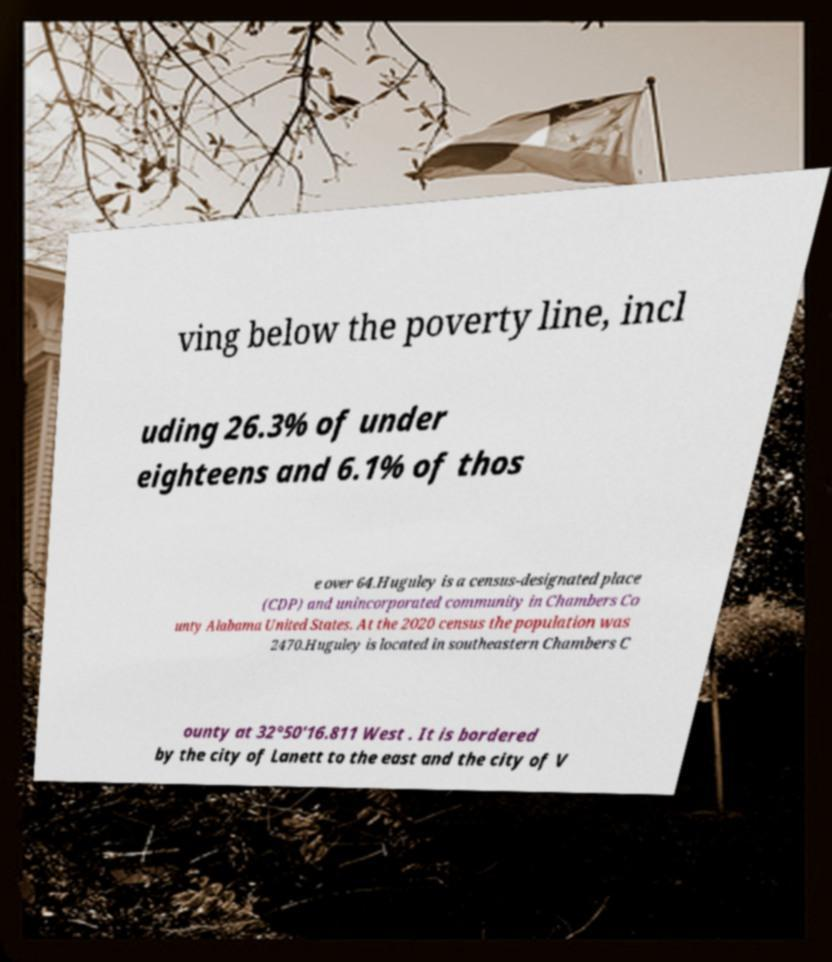Can you accurately transcribe the text from the provided image for me? ving below the poverty line, incl uding 26.3% of under eighteens and 6.1% of thos e over 64.Huguley is a census-designated place (CDP) and unincorporated community in Chambers Co unty Alabama United States. At the 2020 census the population was 2470.Huguley is located in southeastern Chambers C ounty at 32°50'16.811 West . It is bordered by the city of Lanett to the east and the city of V 